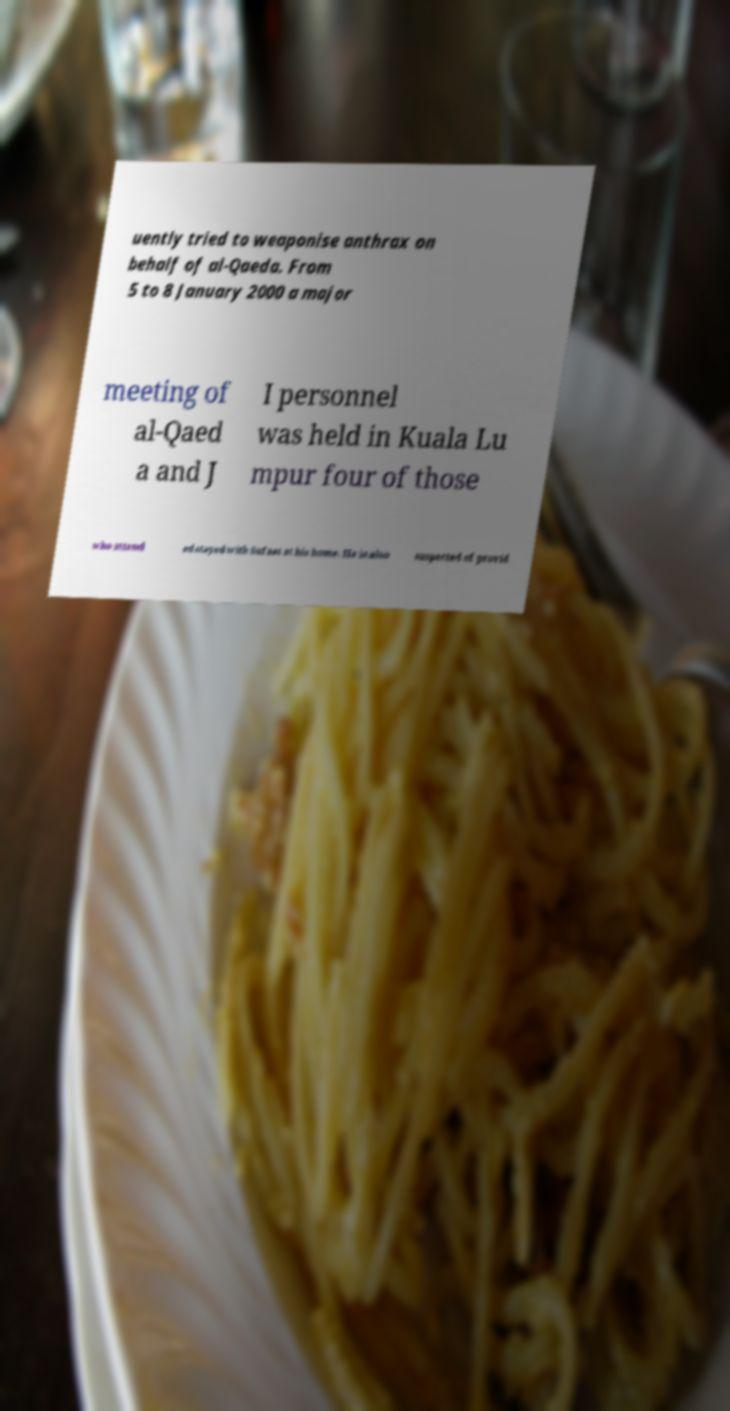Can you read and provide the text displayed in the image?This photo seems to have some interesting text. Can you extract and type it out for me? uently tried to weaponise anthrax on behalf of al-Qaeda. From 5 to 8 January 2000 a major meeting of al-Qaed a and J I personnel was held in Kuala Lu mpur four of those who attend ed stayed with Sufaat at his home. He is also suspected of provid 